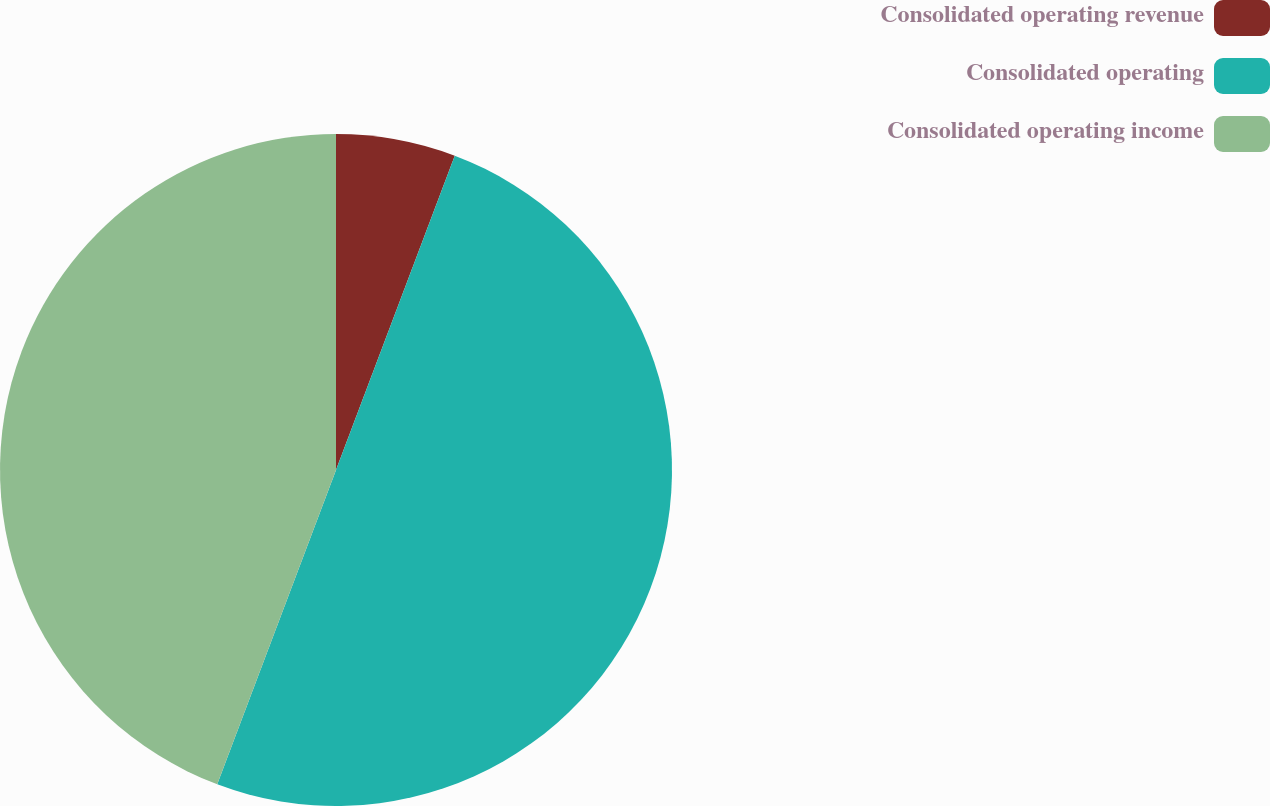<chart> <loc_0><loc_0><loc_500><loc_500><pie_chart><fcel>Consolidated operating revenue<fcel>Consolidated operating<fcel>Consolidated operating income<nl><fcel>5.75%<fcel>50.0%<fcel>44.25%<nl></chart> 